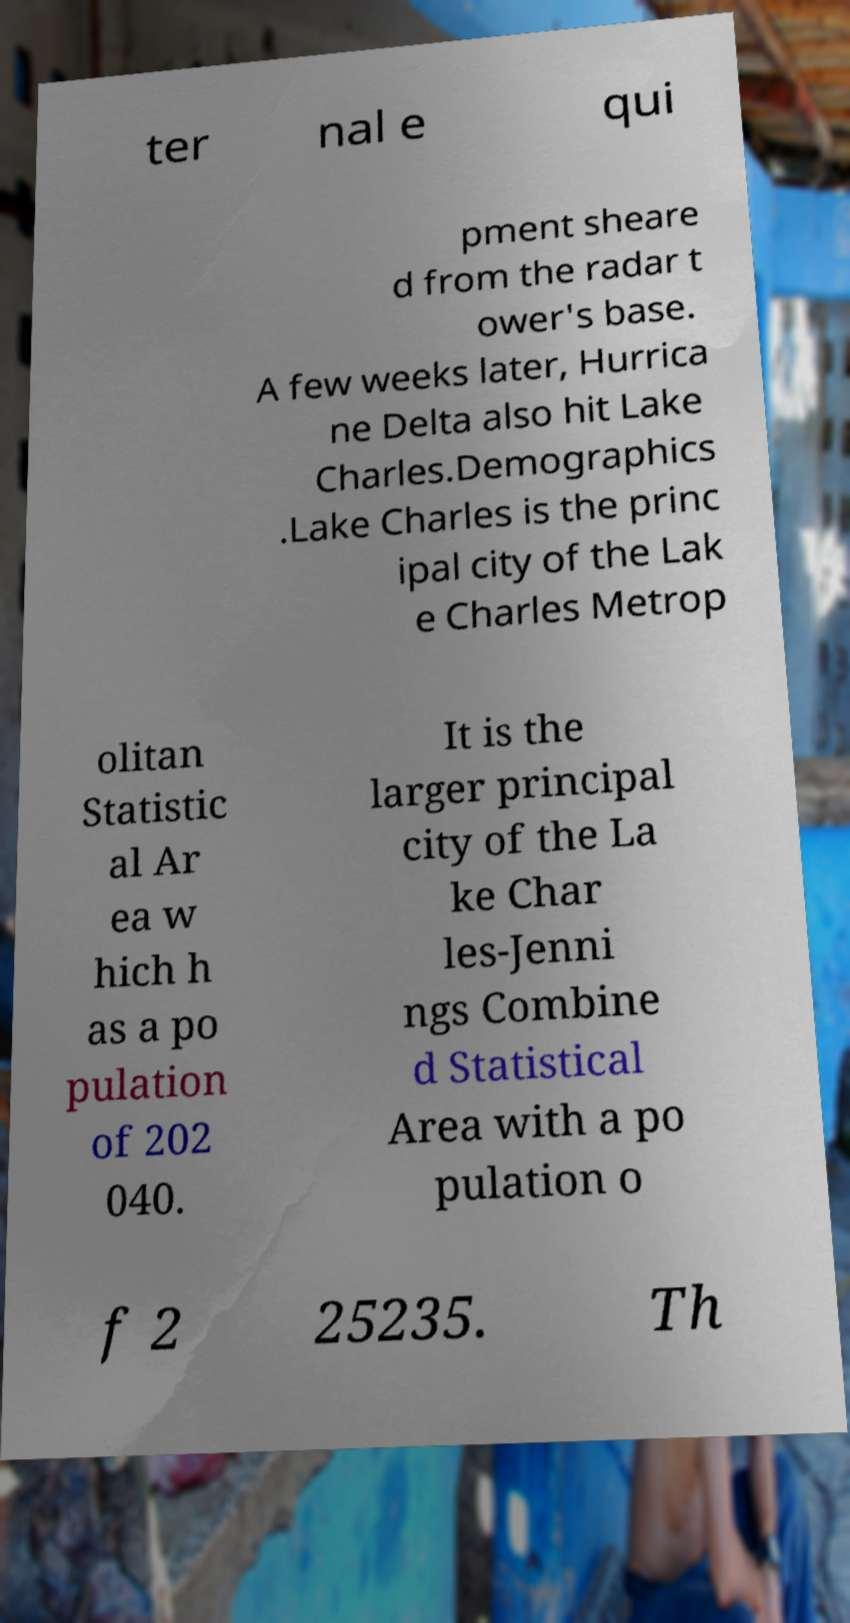Could you extract and type out the text from this image? ter nal e qui pment sheare d from the radar t ower's base. A few weeks later, Hurrica ne Delta also hit Lake Charles.Demographics .Lake Charles is the princ ipal city of the Lak e Charles Metrop olitan Statistic al Ar ea w hich h as a po pulation of 202 040. It is the larger principal city of the La ke Char les-Jenni ngs Combine d Statistical Area with a po pulation o f 2 25235. Th 